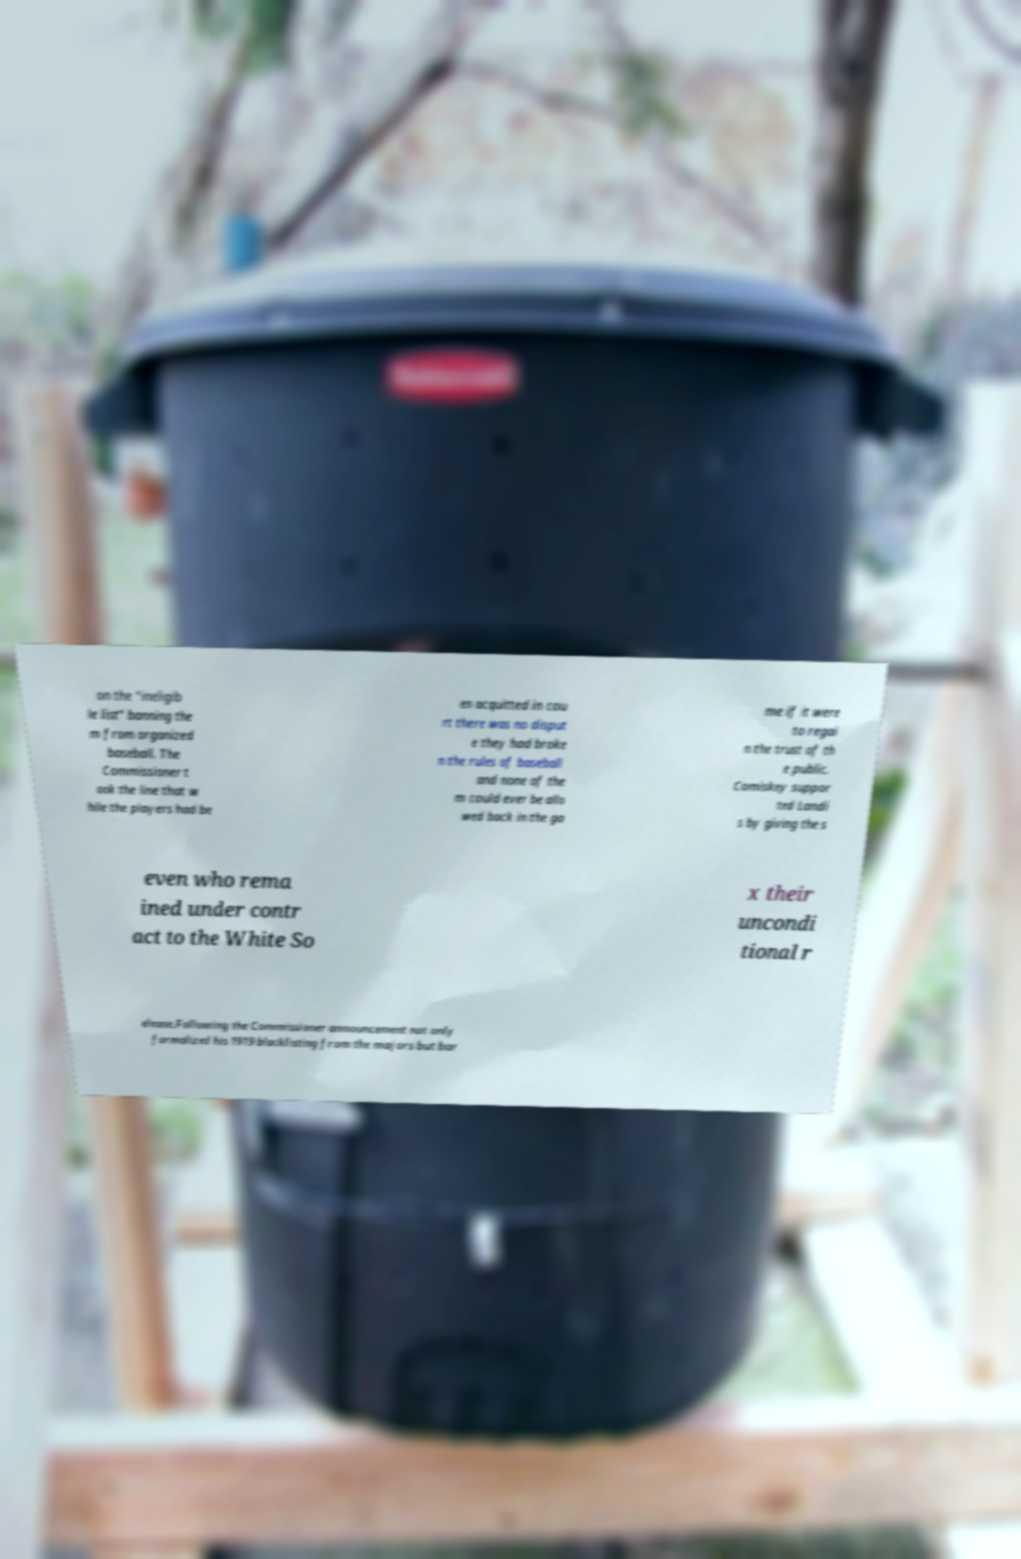Please identify and transcribe the text found in this image. on the "ineligib le list" banning the m from organized baseball. The Commissioner t ook the line that w hile the players had be en acquitted in cou rt there was no disput e they had broke n the rules of baseball and none of the m could ever be allo wed back in the ga me if it were to regai n the trust of th e public. Comiskey suppor ted Landi s by giving the s even who rema ined under contr act to the White So x their uncondi tional r elease.Following the Commissioner announcement not only formalized his 1919 blacklisting from the majors but bar 